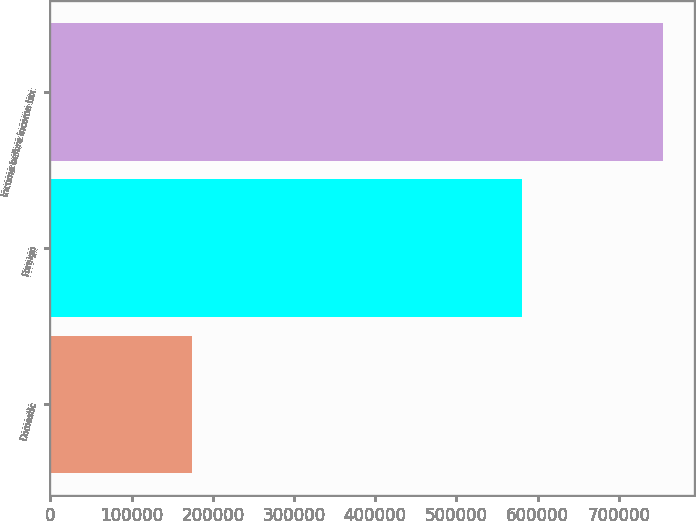Convert chart to OTSL. <chart><loc_0><loc_0><loc_500><loc_500><bar_chart><fcel>Domestic<fcel>Foreign<fcel>Income before income tax<nl><fcel>173865<fcel>580971<fcel>754836<nl></chart> 